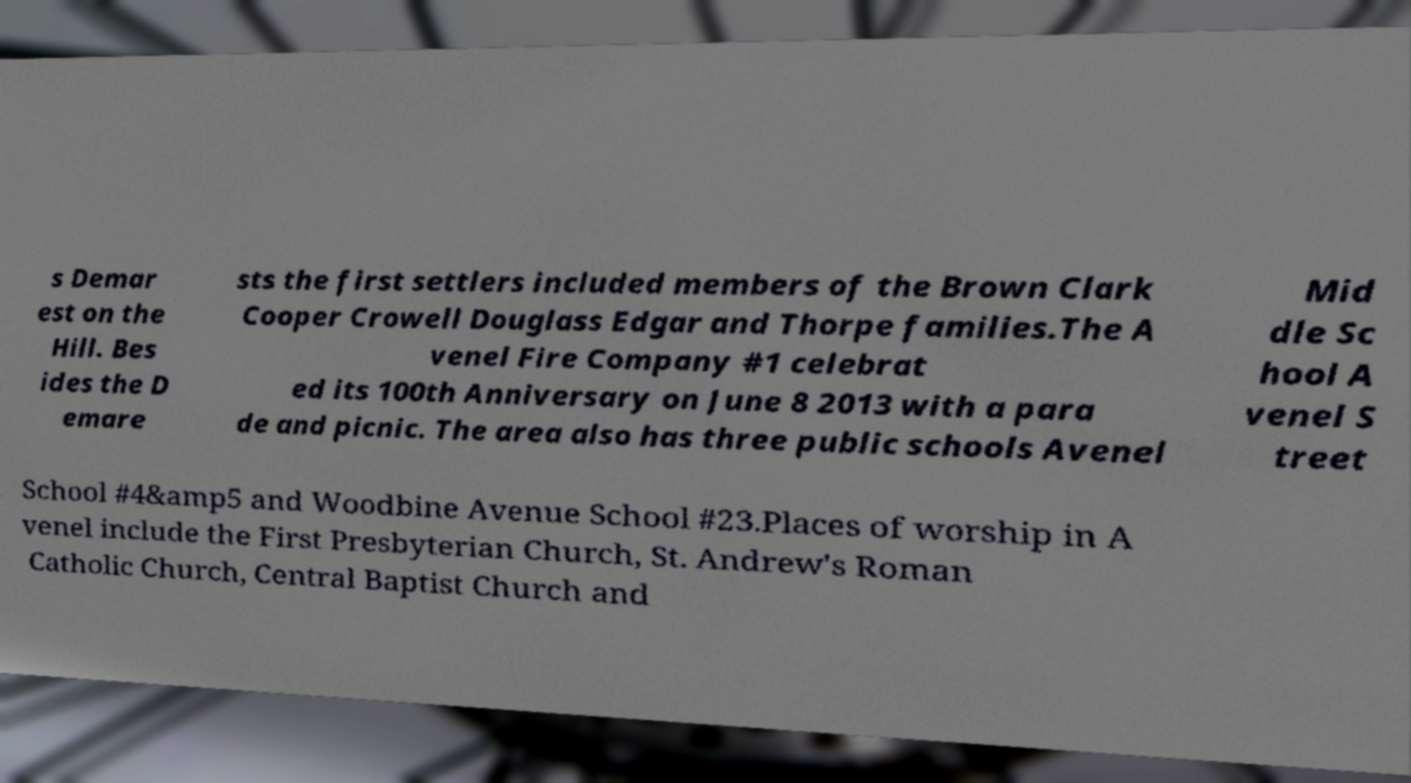Please read and relay the text visible in this image. What does it say? s Demar est on the Hill. Bes ides the D emare sts the first settlers included members of the Brown Clark Cooper Crowell Douglass Edgar and Thorpe families.The A venel Fire Company #1 celebrat ed its 100th Anniversary on June 8 2013 with a para de and picnic. The area also has three public schools Avenel Mid dle Sc hool A venel S treet School #4&amp5 and Woodbine Avenue School #23.Places of worship in A venel include the First Presbyterian Church, St. Andrew's Roman Catholic Church, Central Baptist Church and 